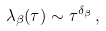<formula> <loc_0><loc_0><loc_500><loc_500>\lambda _ { \beta } ( \tau ) \sim \tau ^ { \delta _ { \beta } } \, ,</formula> 